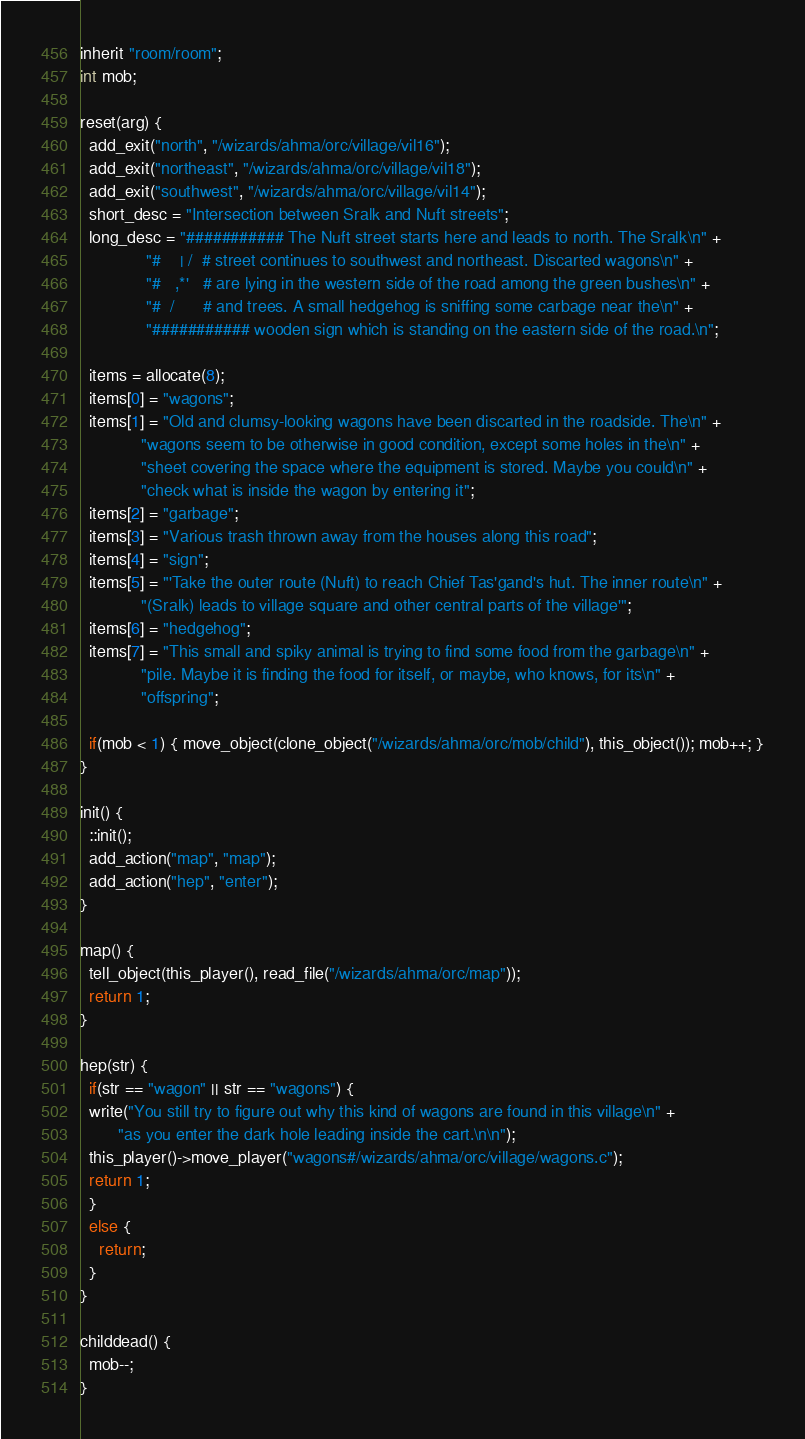Convert code to text. <code><loc_0><loc_0><loc_500><loc_500><_C_>inherit "room/room";
int mob;

reset(arg) {
  add_exit("north", "/wizards/ahma/orc/village/vil16");
  add_exit("northeast", "/wizards/ahma/orc/village/vil18");
  add_exit("southwest", "/wizards/ahma/orc/village/vil14");
  short_desc = "Intersection between Sralk and Nuft streets";
  long_desc = "########### The Nuft street starts here and leads to north. The Sralk\n" + 
              "#    | /  # street continues to southwest and northeast. Discarted wagons\n" + 
              "#   ,*'   # are lying in the western side of the road among the green bushes\n" + 
              "#  /      # and trees. A small hedgehog is sniffing some carbage near the\n" + 
              "########### wooden sign which is standing on the eastern side of the road.\n";

  items = allocate(8);
  items[0] = "wagons";
  items[1] = "Old and clumsy-looking wagons have been discarted in the roadside. The\n" + 
             "wagons seem to be otherwise in good condition, except some holes in the\n" + 
             "sheet covering the space where the equipment is stored. Maybe you could\n" + 
             "check what is inside the wagon by entering it";
  items[2] = "garbage";
  items[3] = "Various trash thrown away from the houses along this road";
  items[4] = "sign";
  items[5] = "'Take the outer route (Nuft) to reach Chief Tas'gand's hut. The inner route\n" +
             "(Sralk) leads to village square and other central parts of the village'";
  items[6] = "hedgehog";
  items[7] = "This small and spiky animal is trying to find some food from the garbage\n" + 
             "pile. Maybe it is finding the food for itself, or maybe, who knows, for its\n" +
             "offspring";

  if(mob < 1) { move_object(clone_object("/wizards/ahma/orc/mob/child"), this_object()); mob++; }
}

init() {
  ::init();
  add_action("map", "map");
  add_action("hep", "enter");
}

map() {
  tell_object(this_player(), read_file("/wizards/ahma/orc/map"));
  return 1;
}

hep(str) {
  if(str == "wagon" || str == "wagons") {
  write("You still try to figure out why this kind of wagons are found in this village\n" + 
        "as you enter the dark hole leading inside the cart.\n\n");
  this_player()->move_player("wagons#/wizards/ahma/orc/village/wagons.c");
  return 1;
  }
  else {
    return;
  }
}

childdead() {
  mob--;
}</code> 